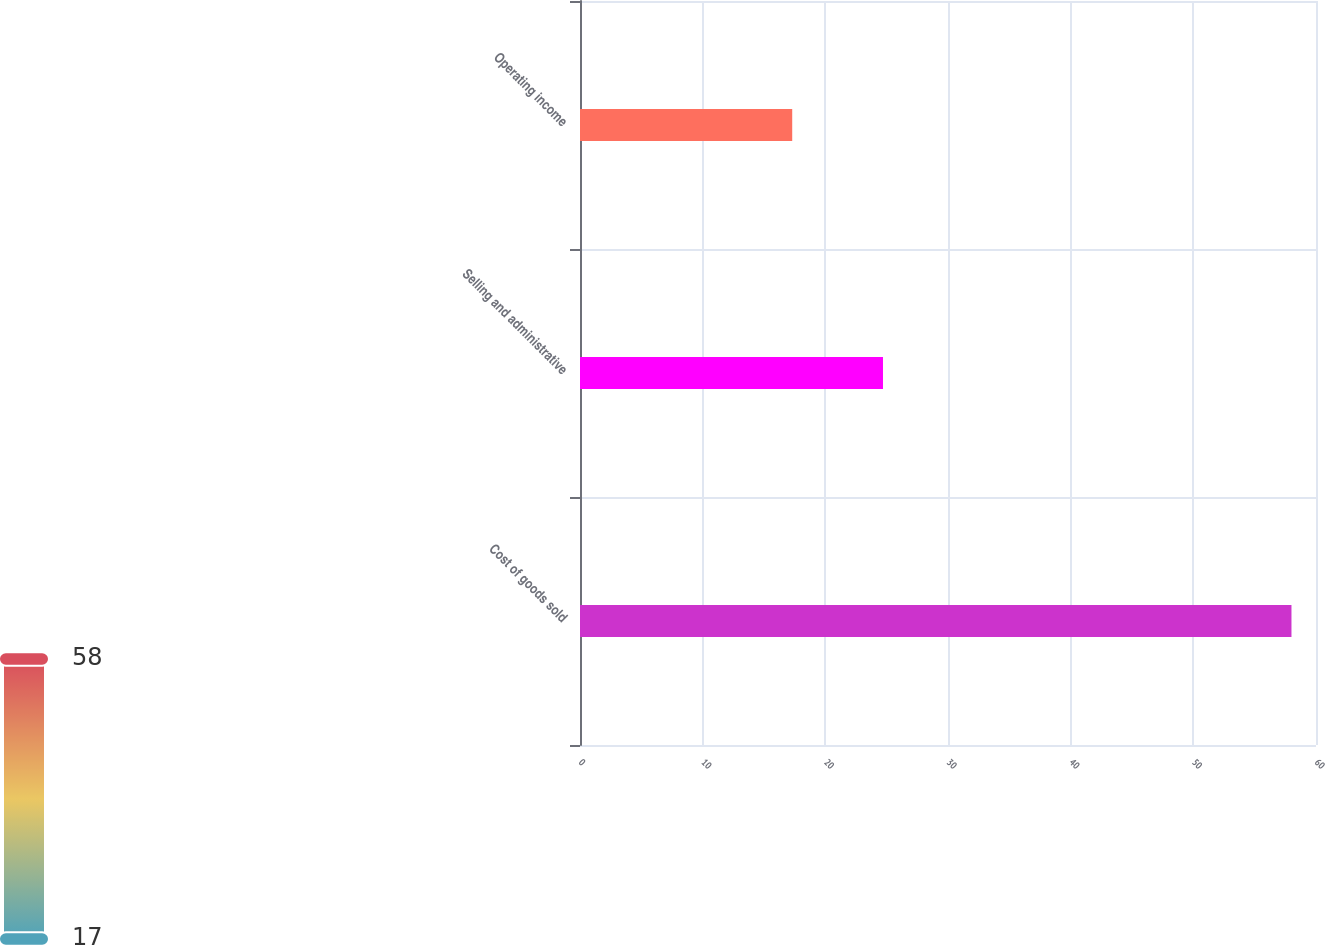Convert chart. <chart><loc_0><loc_0><loc_500><loc_500><bar_chart><fcel>Cost of goods sold<fcel>Selling and administrative<fcel>Operating income<nl><fcel>58<fcel>24.7<fcel>17.3<nl></chart> 